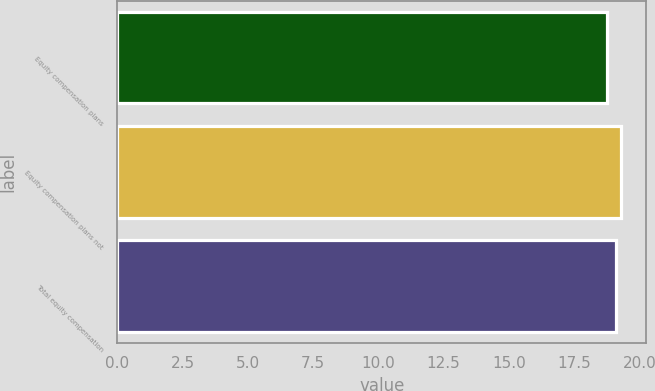<chart> <loc_0><loc_0><loc_500><loc_500><bar_chart><fcel>Equity compensation plans<fcel>Equity compensation plans not<fcel>Total equity compensation<nl><fcel>18.75<fcel>19.29<fcel>19.12<nl></chart> 